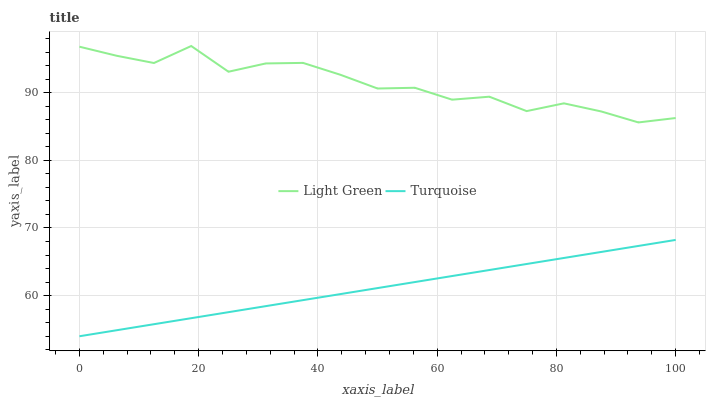Does Turquoise have the minimum area under the curve?
Answer yes or no. Yes. Does Light Green have the maximum area under the curve?
Answer yes or no. Yes. Does Light Green have the minimum area under the curve?
Answer yes or no. No. Is Turquoise the smoothest?
Answer yes or no. Yes. Is Light Green the roughest?
Answer yes or no. Yes. Is Light Green the smoothest?
Answer yes or no. No. Does Turquoise have the lowest value?
Answer yes or no. Yes. Does Light Green have the lowest value?
Answer yes or no. No. Does Light Green have the highest value?
Answer yes or no. Yes. Is Turquoise less than Light Green?
Answer yes or no. Yes. Is Light Green greater than Turquoise?
Answer yes or no. Yes. Does Turquoise intersect Light Green?
Answer yes or no. No. 